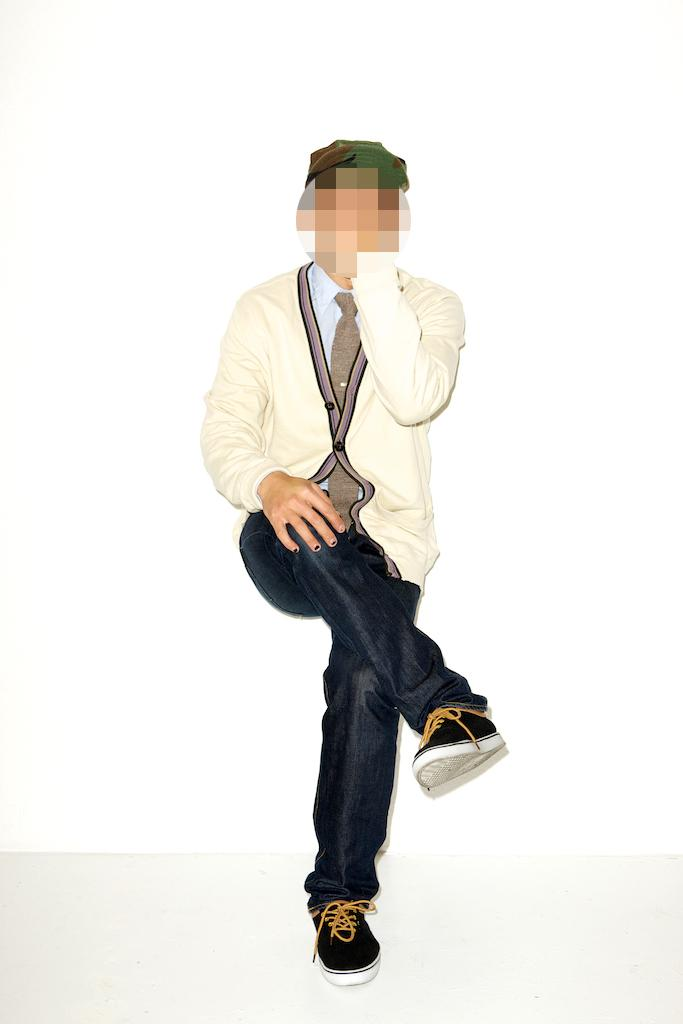What is the main subject of the image? There is a person in the image. What is the person doing in the image? The person is hiding his face. What type of store can be seen in the background of the image? There is no store present in the image; it only features a person hiding his face. What kind of scarecrow is standing next to the person in the image? There is no scarecrow present in the image; it only features a person hiding his face. 